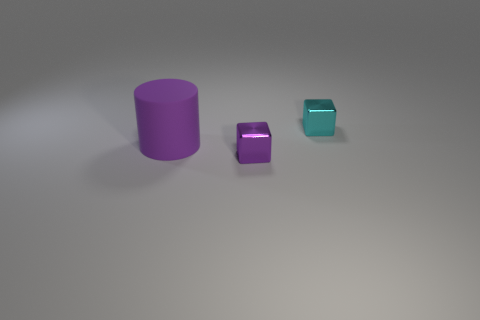Is there a large matte cylinder that has the same color as the big object? no 